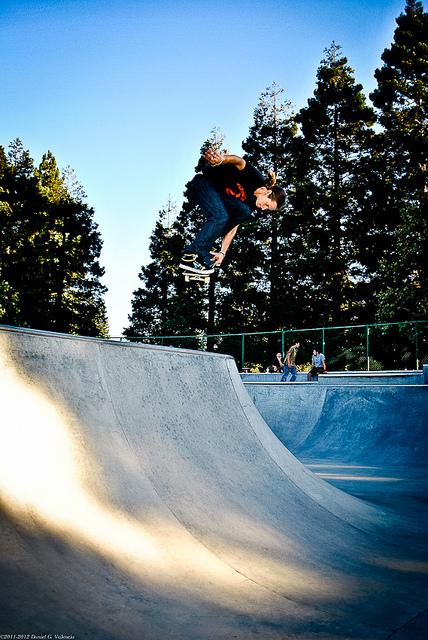Where is this activity taking place?
Write a very short answer. Skateboard park. Is the skateboard in the air?
Short answer required. Yes. Is it snowing outside?
Give a very brief answer. No. 